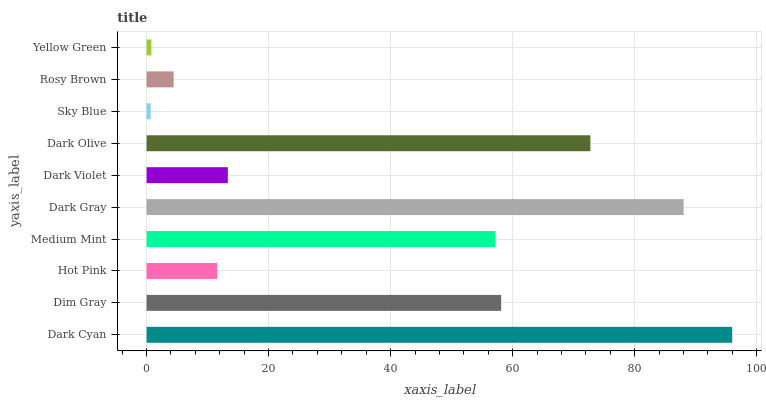Is Sky Blue the minimum?
Answer yes or no. Yes. Is Dark Cyan the maximum?
Answer yes or no. Yes. Is Dim Gray the minimum?
Answer yes or no. No. Is Dim Gray the maximum?
Answer yes or no. No. Is Dark Cyan greater than Dim Gray?
Answer yes or no. Yes. Is Dim Gray less than Dark Cyan?
Answer yes or no. Yes. Is Dim Gray greater than Dark Cyan?
Answer yes or no. No. Is Dark Cyan less than Dim Gray?
Answer yes or no. No. Is Medium Mint the high median?
Answer yes or no. Yes. Is Dark Violet the low median?
Answer yes or no. Yes. Is Dim Gray the high median?
Answer yes or no. No. Is Sky Blue the low median?
Answer yes or no. No. 